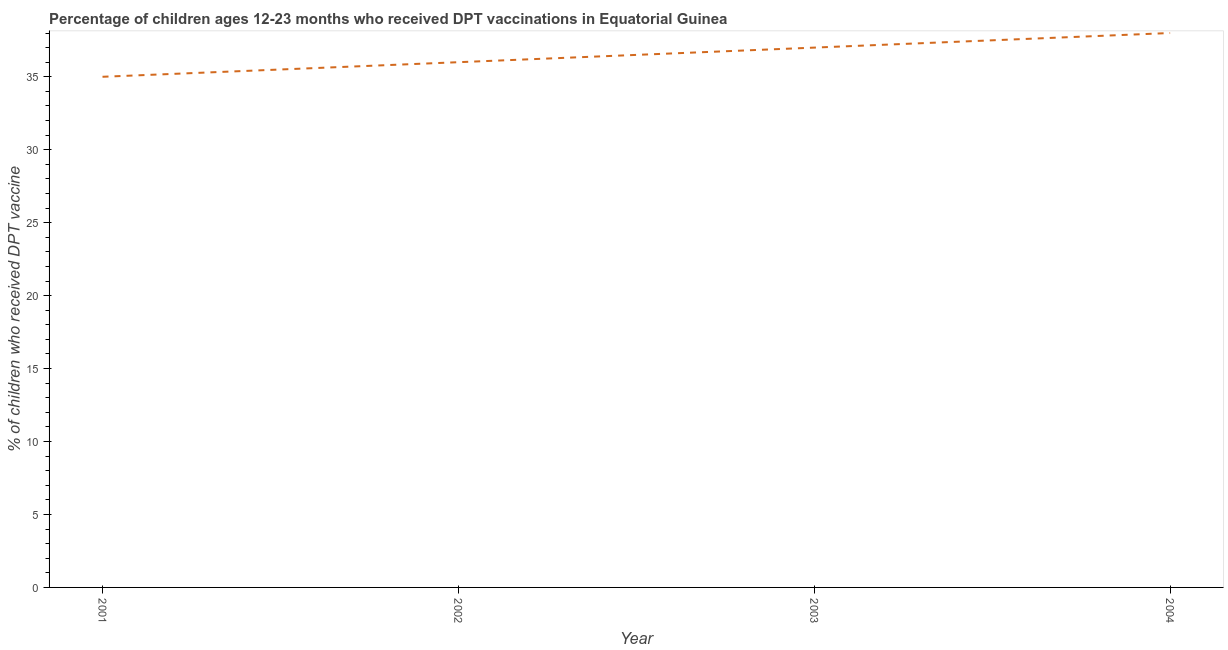What is the percentage of children who received dpt vaccine in 2001?
Your response must be concise. 35. Across all years, what is the maximum percentage of children who received dpt vaccine?
Provide a succinct answer. 38. Across all years, what is the minimum percentage of children who received dpt vaccine?
Your answer should be very brief. 35. In which year was the percentage of children who received dpt vaccine maximum?
Provide a succinct answer. 2004. What is the sum of the percentage of children who received dpt vaccine?
Make the answer very short. 146. What is the difference between the percentage of children who received dpt vaccine in 2001 and 2003?
Provide a short and direct response. -2. What is the average percentage of children who received dpt vaccine per year?
Provide a short and direct response. 36.5. What is the median percentage of children who received dpt vaccine?
Give a very brief answer. 36.5. Do a majority of the years between 2001 and 2003 (inclusive) have percentage of children who received dpt vaccine greater than 19 %?
Your response must be concise. Yes. What is the ratio of the percentage of children who received dpt vaccine in 2002 to that in 2004?
Offer a very short reply. 0.95. Is the percentage of children who received dpt vaccine in 2001 less than that in 2004?
Provide a short and direct response. Yes. Is the sum of the percentage of children who received dpt vaccine in 2003 and 2004 greater than the maximum percentage of children who received dpt vaccine across all years?
Offer a very short reply. Yes. What is the difference between the highest and the lowest percentage of children who received dpt vaccine?
Ensure brevity in your answer.  3. In how many years, is the percentage of children who received dpt vaccine greater than the average percentage of children who received dpt vaccine taken over all years?
Ensure brevity in your answer.  2. Does the percentage of children who received dpt vaccine monotonically increase over the years?
Offer a very short reply. Yes. How many lines are there?
Your answer should be compact. 1. What is the difference between two consecutive major ticks on the Y-axis?
Provide a succinct answer. 5. Does the graph contain any zero values?
Your answer should be compact. No. Does the graph contain grids?
Ensure brevity in your answer.  No. What is the title of the graph?
Your response must be concise. Percentage of children ages 12-23 months who received DPT vaccinations in Equatorial Guinea. What is the label or title of the Y-axis?
Offer a very short reply. % of children who received DPT vaccine. What is the % of children who received DPT vaccine of 2001?
Your answer should be very brief. 35. What is the % of children who received DPT vaccine of 2002?
Provide a short and direct response. 36. What is the % of children who received DPT vaccine in 2003?
Ensure brevity in your answer.  37. What is the % of children who received DPT vaccine in 2004?
Ensure brevity in your answer.  38. What is the difference between the % of children who received DPT vaccine in 2001 and 2002?
Provide a short and direct response. -1. What is the ratio of the % of children who received DPT vaccine in 2001 to that in 2003?
Your response must be concise. 0.95. What is the ratio of the % of children who received DPT vaccine in 2001 to that in 2004?
Your answer should be very brief. 0.92. What is the ratio of the % of children who received DPT vaccine in 2002 to that in 2004?
Keep it short and to the point. 0.95. What is the ratio of the % of children who received DPT vaccine in 2003 to that in 2004?
Your answer should be compact. 0.97. 